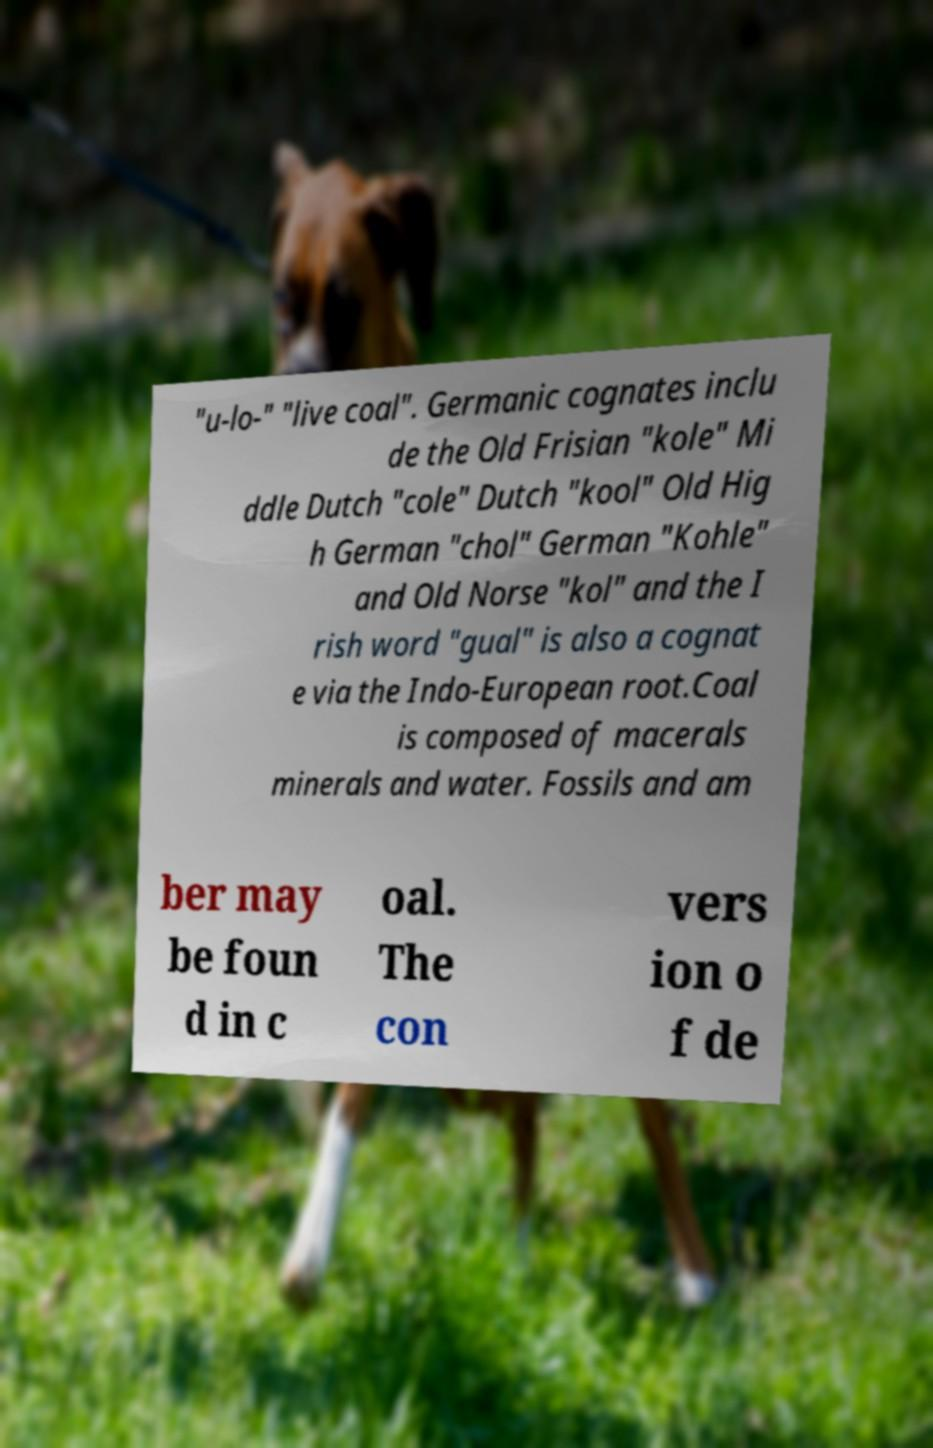What messages or text are displayed in this image? I need them in a readable, typed format. "u-lo-" "live coal". Germanic cognates inclu de the Old Frisian "kole" Mi ddle Dutch "cole" Dutch "kool" Old Hig h German "chol" German "Kohle" and Old Norse "kol" and the I rish word "gual" is also a cognat e via the Indo-European root.Coal is composed of macerals minerals and water. Fossils and am ber may be foun d in c oal. The con vers ion o f de 